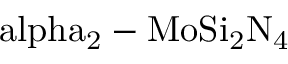<formula> <loc_0><loc_0><loc_500><loc_500>\ a l p h a _ { 2 } - M o S i _ { 2 } N _ { 4 }</formula> 